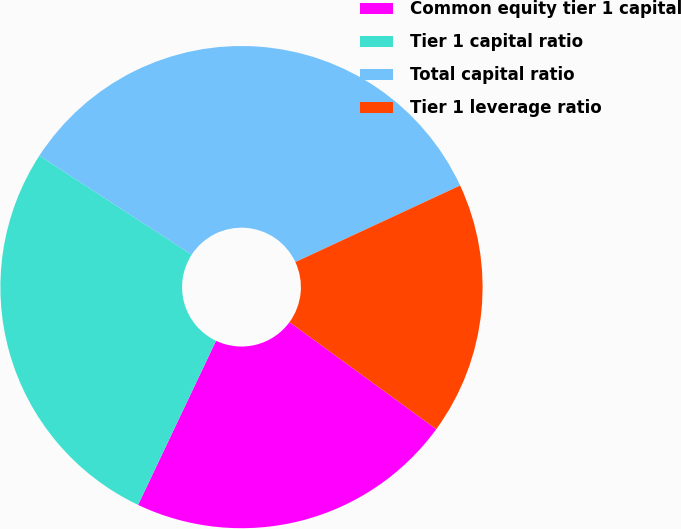Convert chart. <chart><loc_0><loc_0><loc_500><loc_500><pie_chart><fcel>Common equity tier 1 capital<fcel>Tier 1 capital ratio<fcel>Total capital ratio<fcel>Tier 1 leverage ratio<nl><fcel>22.03%<fcel>27.12%<fcel>33.9%<fcel>16.95%<nl></chart> 